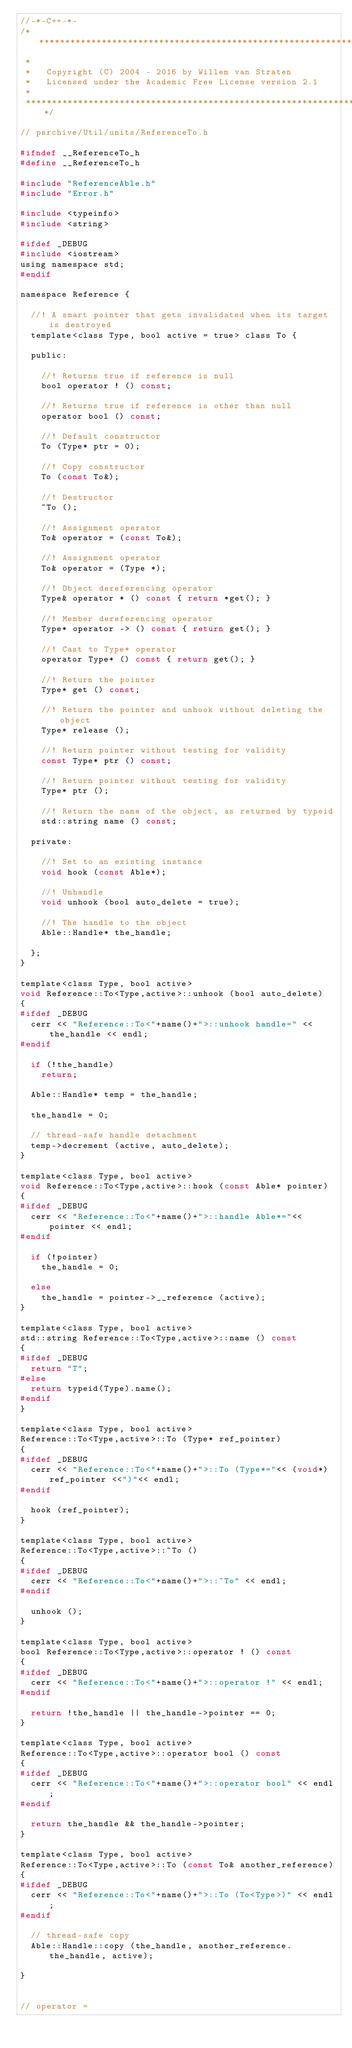Convert code to text. <code><loc_0><loc_0><loc_500><loc_500><_C_>//-*-C++-*-
/***************************************************************************
 *
 *   Copyright (C) 2004 - 2016 by Willem van Straten
 *   Licensed under the Academic Free License version 2.1
 *
 ***************************************************************************/

// psrchive/Util/units/ReferenceTo.h

#ifndef __ReferenceTo_h
#define __ReferenceTo_h

#include "ReferenceAble.h"
#include "Error.h"

#include <typeinfo>
#include <string>

#ifdef _DEBUG
#include <iostream>
using namespace std;
#endif

namespace Reference {

  //! A smart pointer that gets invalidated when its target is destroyed
  template<class Type, bool active = true> class To {

  public:

    //! Returns true if reference is null
    bool operator ! () const;
    
    //! Returns true if reference is other than null
    operator bool () const;
    
    //! Default constructor
    To (Type* ptr = 0);
    
    //! Copy constructor
    To (const To&);
    
    //! Destructor
    ~To ();
    
    //! Assignment operator
    To& operator = (const To&);

    //! Assignment operator
    To& operator = (Type *);
    
    //! Object dereferencing operator
    Type& operator * () const { return *get(); }
    
    //! Member dereferencing operator
    Type* operator -> () const { return get(); }
    
    //! Cast to Type* operator
    operator Type* () const { return get(); }

    //! Return the pointer
    Type* get () const;
    
    //! Return the pointer and unhook without deleting the object
    Type* release ();
    
    //! Return pointer without testing for validity
    const Type* ptr () const;

    //! Return pointer without testing for validity
    Type* ptr ();

    //! Return the name of the object, as returned by typeid
    std::string name () const;

  private:

    //! Set to an existing instance
    void hook (const Able*);

    //! Unhandle
    void unhook (bool auto_delete = true);

    //! The handle to the object
    Able::Handle* the_handle;
    
  };
}

template<class Type, bool active>
void Reference::To<Type,active>::unhook (bool auto_delete)
{
#ifdef _DEBUG
  cerr << "Reference::To<"+name()+">::unhook handle=" << the_handle << endl;
#endif

  if (!the_handle)
    return;

  Able::Handle* temp = the_handle;

  the_handle = 0;

  // thread-safe handle detachment
  temp->decrement (active, auto_delete);
}

template<class Type, bool active>
void Reference::To<Type,active>::hook (const Able* pointer)
{
#ifdef _DEBUG
  cerr << "Reference::To<"+name()+">::handle Able*="<< pointer << endl;
#endif

  if (!pointer)
    the_handle = 0;

  else
    the_handle = pointer->__reference (active);
}

template<class Type, bool active>
std::string Reference::To<Type,active>::name () const
{
#ifdef _DEBUG
  return "T";
#else
  return typeid(Type).name();
#endif
}

template<class Type, bool active>
Reference::To<Type,active>::To (Type* ref_pointer)
{
#ifdef _DEBUG
  cerr << "Reference::To<"+name()+">::To (Type*="<< (void*)ref_pointer <<")"<< endl;
#endif

  hook (ref_pointer);
}

template<class Type, bool active>
Reference::To<Type,active>::~To ()
{ 
#ifdef _DEBUG
  cerr << "Reference::To<"+name()+">::~To" << endl;
#endif

  unhook ();
}

template<class Type, bool active>
bool Reference::To<Type,active>::operator ! () const
{
#ifdef _DEBUG
  cerr << "Reference::To<"+name()+">::operator !" << endl;
#endif

  return !the_handle || the_handle->pointer == 0;
}

template<class Type, bool active>
Reference::To<Type,active>::operator bool () const
{
#ifdef _DEBUG
  cerr << "Reference::To<"+name()+">::operator bool" << endl;
#endif

  return the_handle && the_handle->pointer;
}

template<class Type, bool active>
Reference::To<Type,active>::To (const To& another_reference)
{
#ifdef _DEBUG
  cerr << "Reference::To<"+name()+">::To (To<Type>)" << endl;
#endif

  // thread-safe copy
  Able::Handle::copy (the_handle, another_reference.the_handle, active);

}


// operator =</code> 